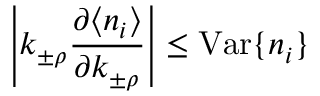<formula> <loc_0><loc_0><loc_500><loc_500>\left | k _ { \pm \rho } \frac { \partial \langle n _ { i } \rangle } { \partial k _ { \pm \rho } } \right | \leq V a r \{ n _ { i } \}</formula> 